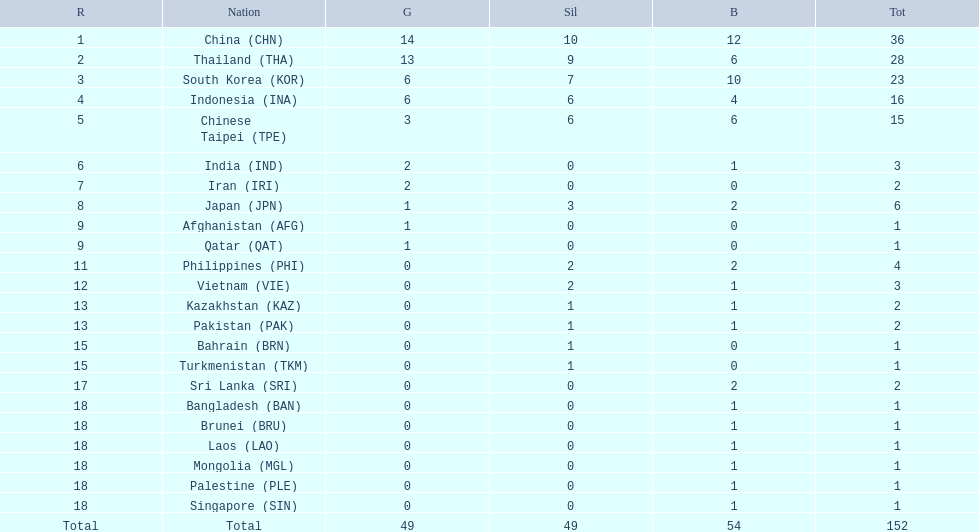How many more medals did india earn compared to pakistan? 1. 